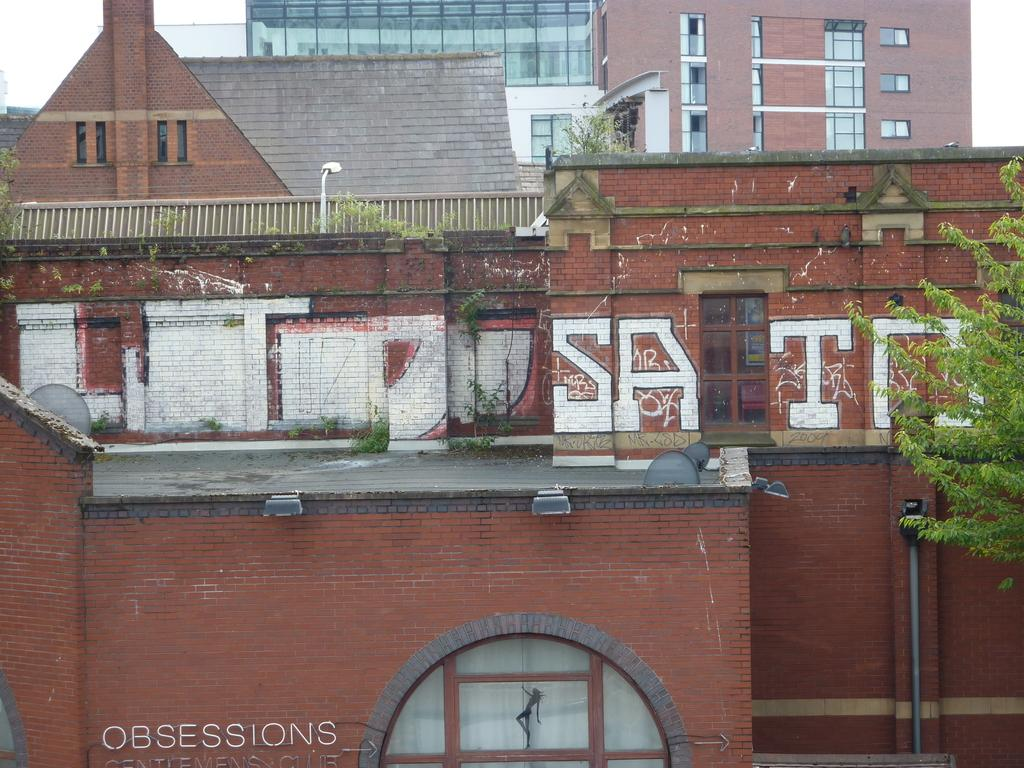What type of structure is visible in the image? There is a building in the image. What is the color of the building? The building is brick-colored. What can be seen on the building? There is something written on the building. What type of vegetation is in the right corner of the image? There is a tree in the right corner of the image. Can you see a group of people trying to escape from quicksand near the building in the image? There is no quicksand or group of people present in the image. 